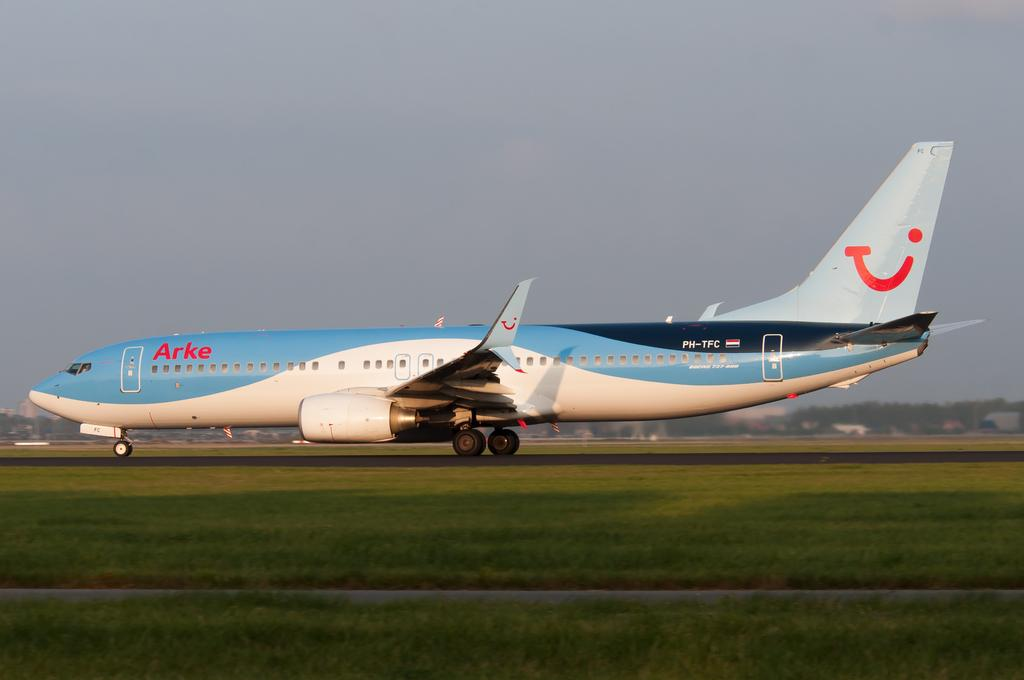Provide a one-sentence caption for the provided image. An ARKE jet liner on the runway ready for takeoff. 